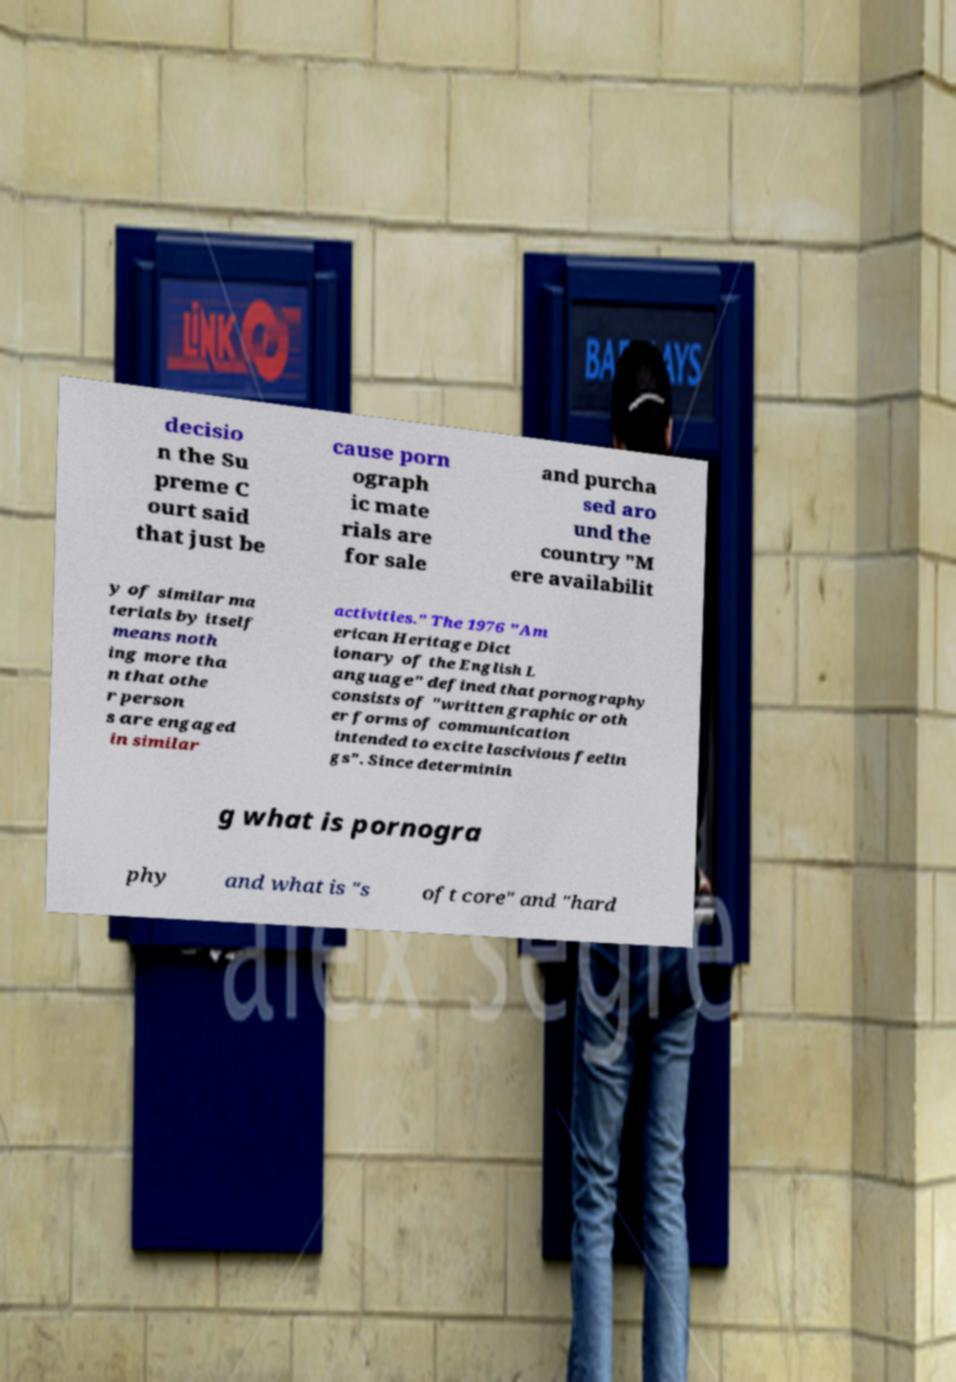What messages or text are displayed in this image? I need them in a readable, typed format. decisio n the Su preme C ourt said that just be cause porn ograph ic mate rials are for sale and purcha sed aro und the country "M ere availabilit y of similar ma terials by itself means noth ing more tha n that othe r person s are engaged in similar activities." The 1976 "Am erican Heritage Dict ionary of the English L anguage" defined that pornography consists of "written graphic or oth er forms of communication intended to excite lascivious feelin gs". Since determinin g what is pornogra phy and what is "s oft core" and "hard 